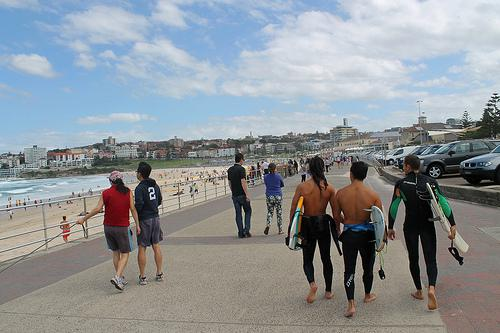Question: where was this photo taken?
Choices:
A. By the road.
B. By the forest.
C. By the city.
D. By the beach.
Answer with the letter. Answer: D Question: how many men are holding surfboards?
Choices:
A. 3.
B. 2.
C. 4.
D. 5.
Answer with the letter. Answer: A Question: what number is on the back of the man on the left's hoodie?
Choices:
A. 3.
B. 1.
C. 2.
D. 0.
Answer with the letter. Answer: C Question: how many animals are in the photo?
Choices:
A. 0.
B. 1.
C. 2.
D. 3.
Answer with the letter. Answer: A Question: what is in the background of the picture?
Choices:
A. Cars.
B. Condos.
C. Mountains.
D. Roads.
Answer with the letter. Answer: B 